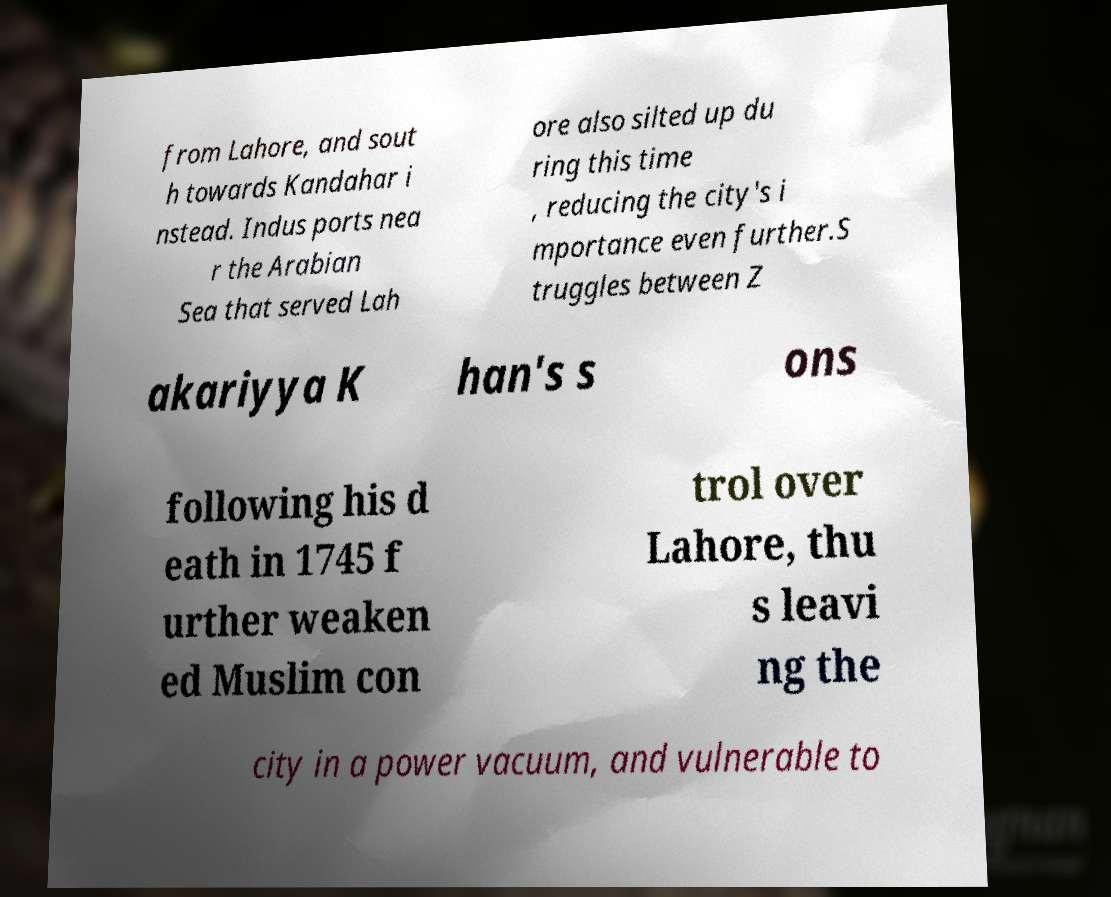Could you extract and type out the text from this image? from Lahore, and sout h towards Kandahar i nstead. Indus ports nea r the Arabian Sea that served Lah ore also silted up du ring this time , reducing the city's i mportance even further.S truggles between Z akariyya K han's s ons following his d eath in 1745 f urther weaken ed Muslim con trol over Lahore, thu s leavi ng the city in a power vacuum, and vulnerable to 